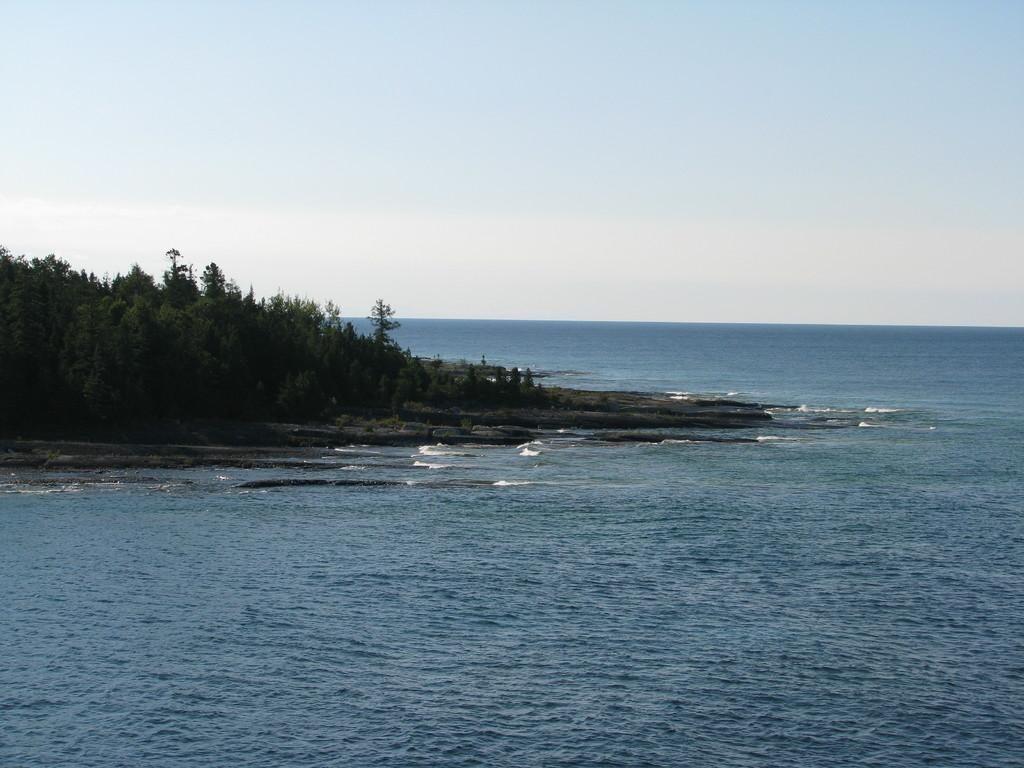What type of vegetation is present in the image? There is a group of trees in the image. What natural element can be seen besides the trees? There is water visible in the image. What is visible in the background of the image? The sky is visible in the background of the image. What type of coal can be seen in the image? There is no coal present in the image. What kind of flowers are growing near the water in the image? There is no mention of flowers in the image; only trees and water are mentioned. 